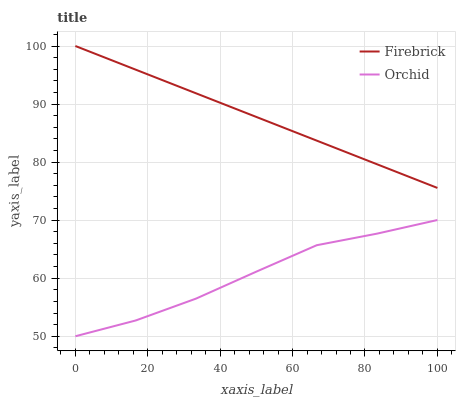Does Orchid have the minimum area under the curve?
Answer yes or no. Yes. Does Firebrick have the maximum area under the curve?
Answer yes or no. Yes. Does Orchid have the maximum area under the curve?
Answer yes or no. No. Is Firebrick the smoothest?
Answer yes or no. Yes. Is Orchid the roughest?
Answer yes or no. Yes. Is Orchid the smoothest?
Answer yes or no. No. Does Orchid have the lowest value?
Answer yes or no. Yes. Does Firebrick have the highest value?
Answer yes or no. Yes. Does Orchid have the highest value?
Answer yes or no. No. Is Orchid less than Firebrick?
Answer yes or no. Yes. Is Firebrick greater than Orchid?
Answer yes or no. Yes. Does Orchid intersect Firebrick?
Answer yes or no. No. 